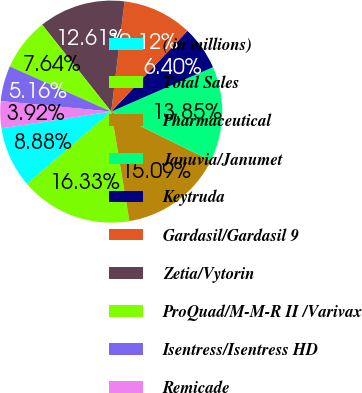<chart> <loc_0><loc_0><loc_500><loc_500><pie_chart><fcel>( in millions)<fcel>Total Sales<fcel>Pharmaceutical<fcel>Januvia/Janumet<fcel>Keytruda<fcel>Gardasil/Gardasil 9<fcel>Zetia/Vytorin<fcel>ProQuad/M-M-R II /Varivax<fcel>Isentress/Isentress HD<fcel>Remicade<nl><fcel>8.88%<fcel>16.32%<fcel>15.08%<fcel>13.84%<fcel>6.4%<fcel>10.12%<fcel>12.6%<fcel>7.64%<fcel>5.16%<fcel>3.92%<nl></chart> 